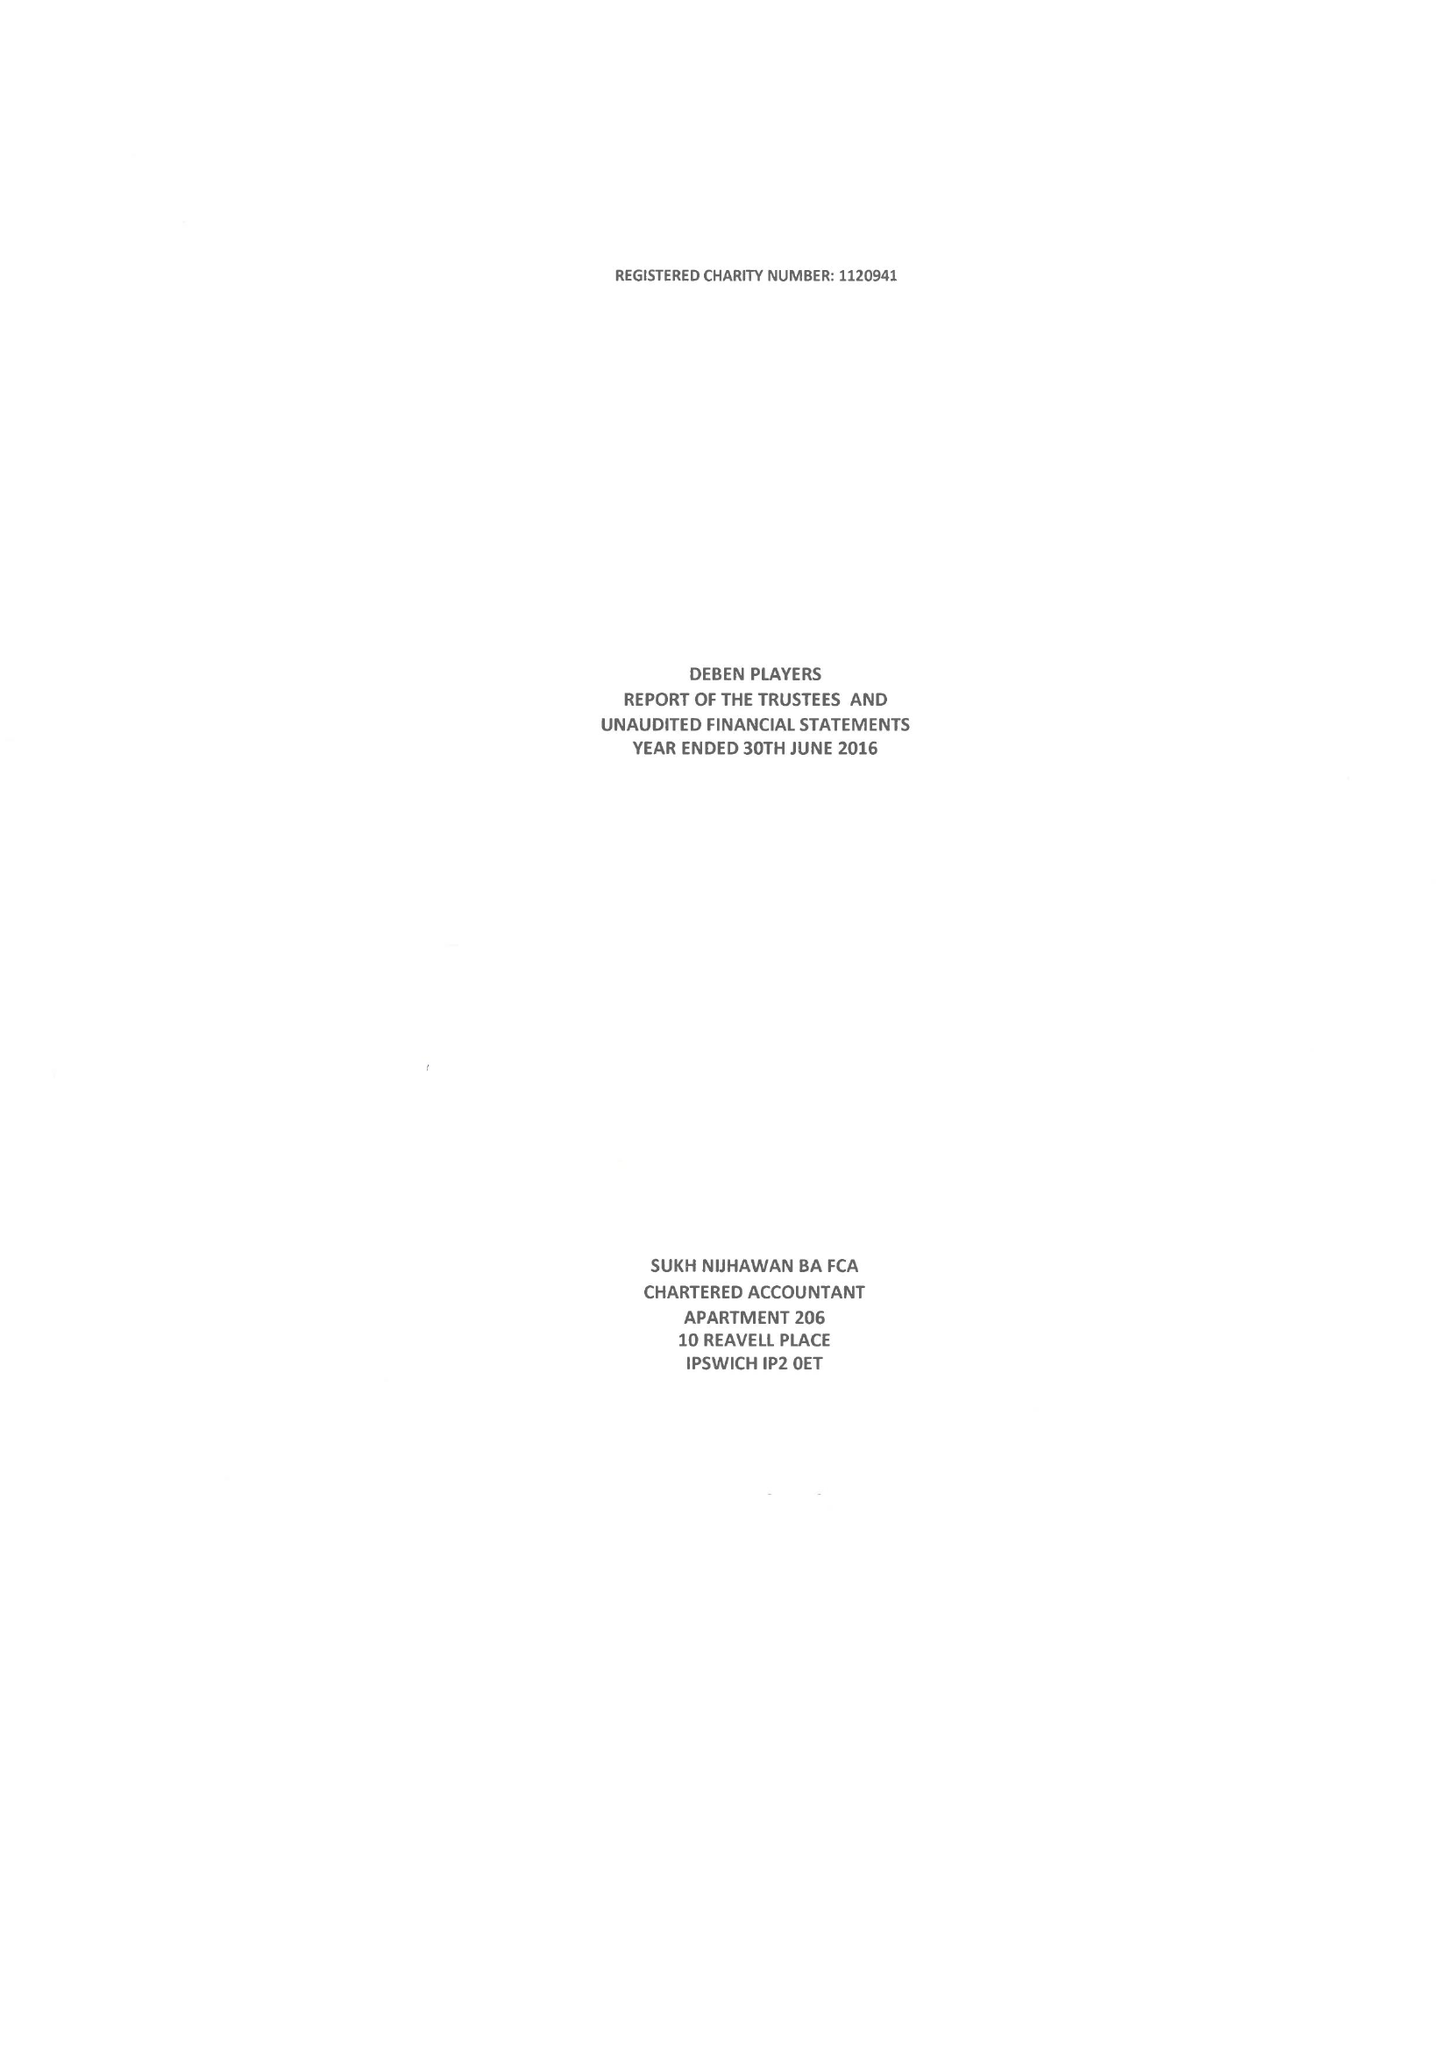What is the value for the report_date?
Answer the question using a single word or phrase. 2016-06-30 